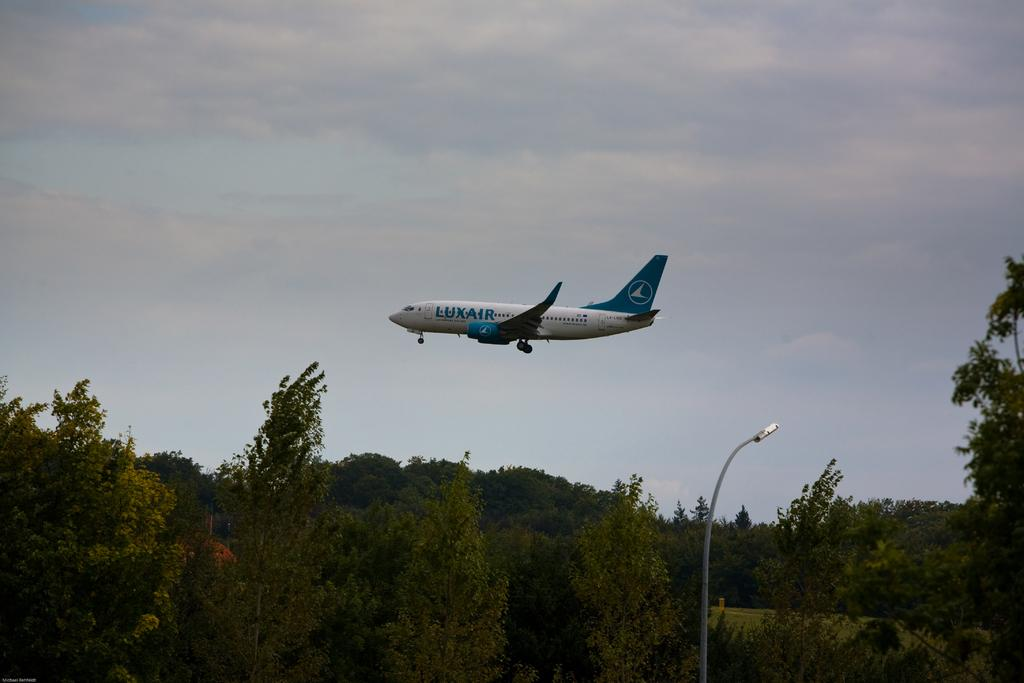<image>
Present a compact description of the photo's key features. A Luxair plane is flying above trees on a cloudy day. 